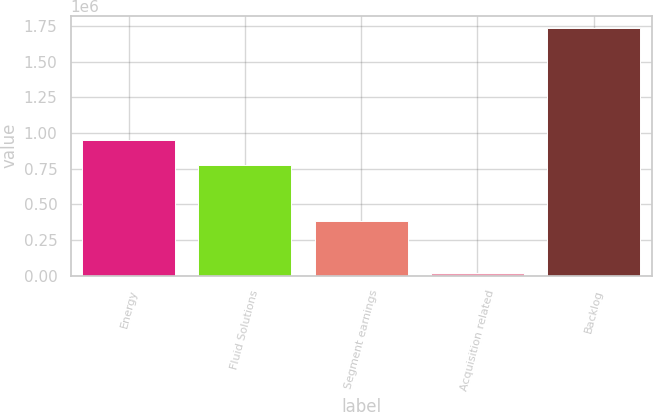<chart> <loc_0><loc_0><loc_500><loc_500><bar_chart><fcel>Energy<fcel>Fluid Solutions<fcel>Segment earnings<fcel>Acquisition related<fcel>Backlog<nl><fcel>950427<fcel>778812<fcel>385317<fcel>19550<fcel>1.7357e+06<nl></chart> 